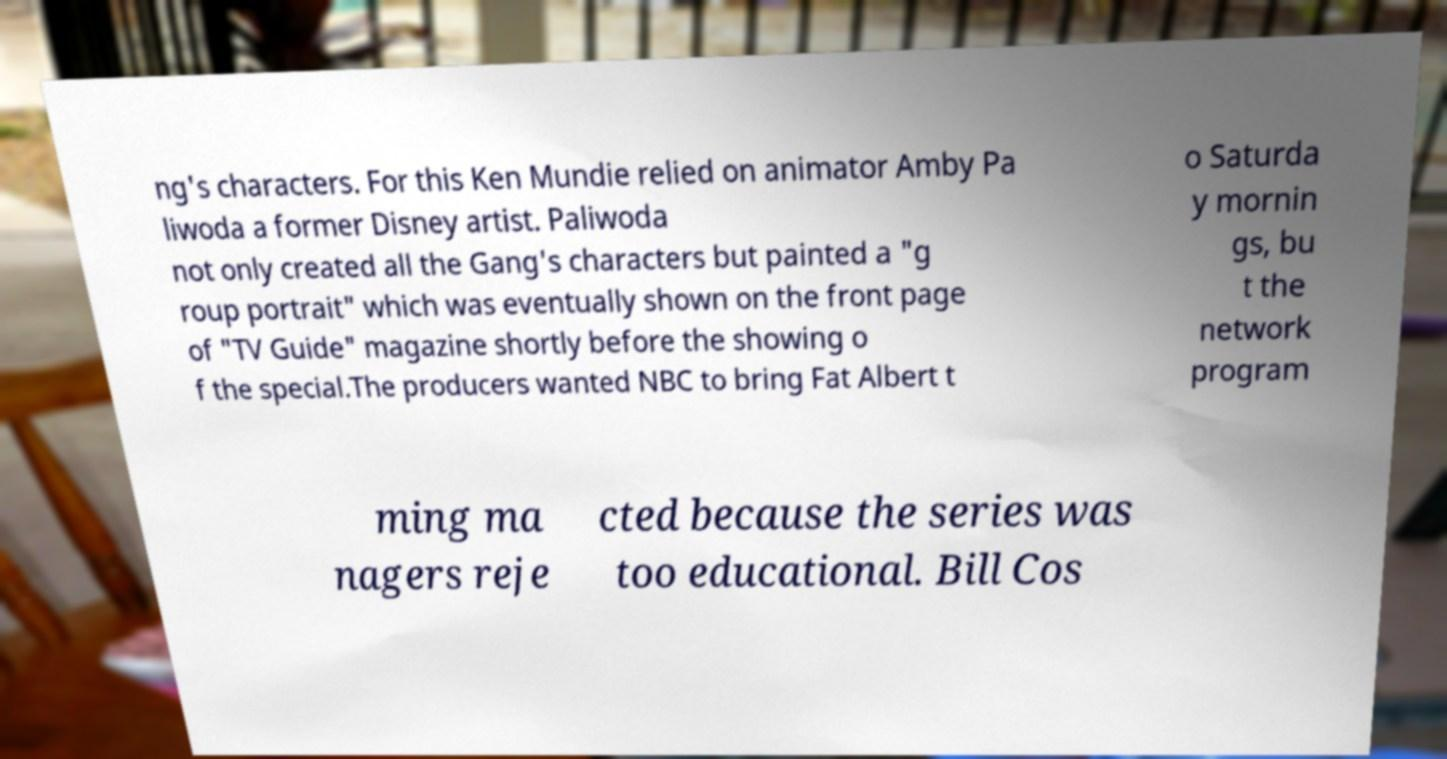Can you accurately transcribe the text from the provided image for me? ng's characters. For this Ken Mundie relied on animator Amby Pa liwoda a former Disney artist. Paliwoda not only created all the Gang's characters but painted a "g roup portrait" which was eventually shown on the front page of "TV Guide" magazine shortly before the showing o f the special.The producers wanted NBC to bring Fat Albert t o Saturda y mornin gs, bu t the network program ming ma nagers reje cted because the series was too educational. Bill Cos 